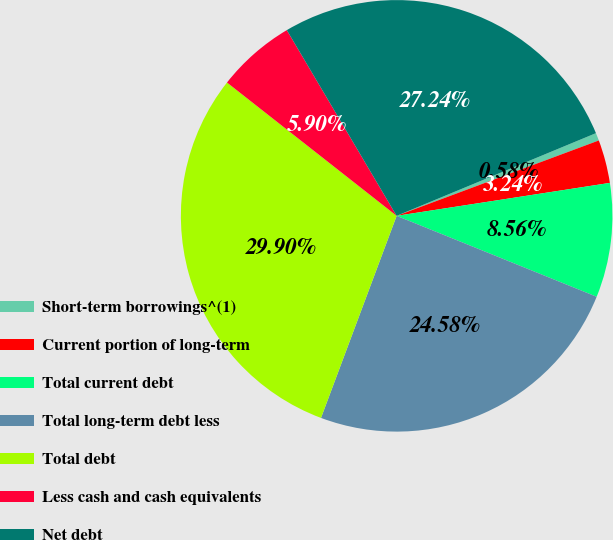Convert chart to OTSL. <chart><loc_0><loc_0><loc_500><loc_500><pie_chart><fcel>Short-term borrowings^(1)<fcel>Current portion of long-term<fcel>Total current debt<fcel>Total long-term debt less<fcel>Total debt<fcel>Less cash and cash equivalents<fcel>Net debt<nl><fcel>0.58%<fcel>3.24%<fcel>8.56%<fcel>24.58%<fcel>29.9%<fcel>5.9%<fcel>27.24%<nl></chart> 